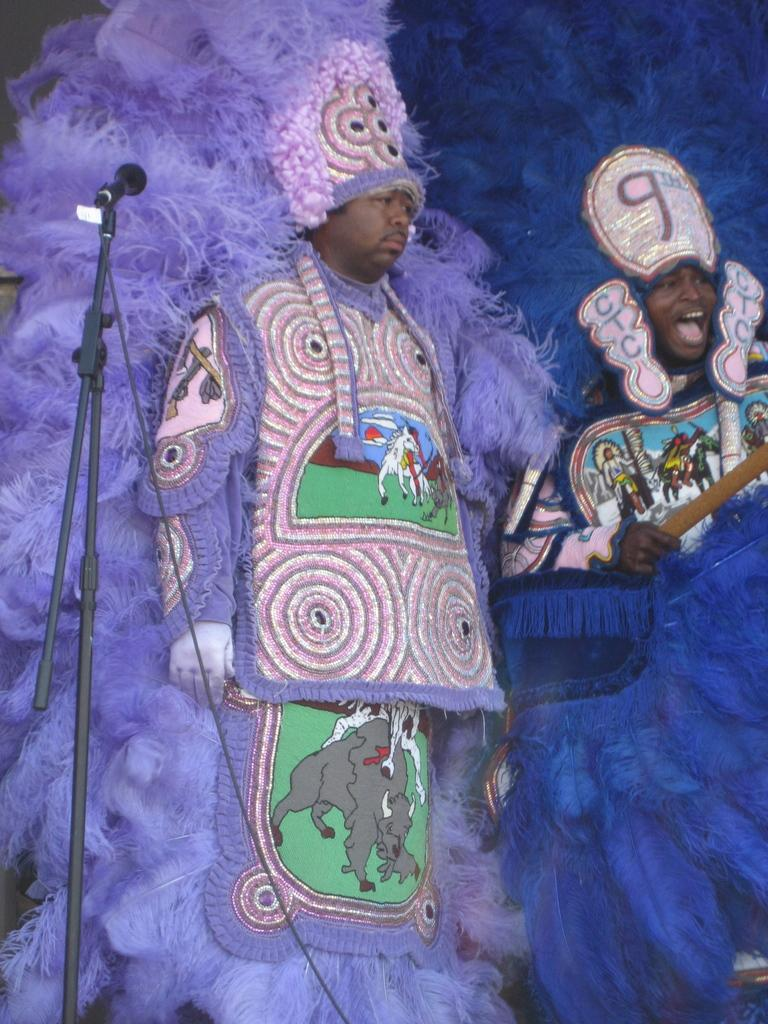How many people are in the image? There are two men in the image. What are the men wearing? The men are wearing costumes. What are the men doing in the image? The men are standing. What object can be seen on the left side of the image? There is a microphone (mic) on the left side of the image. What type of eggs are the men using to read in the image? There are no eggs or reading materials present in the image. Can you tell me where the scissors are located in the image? There are no scissors visible in the image. 